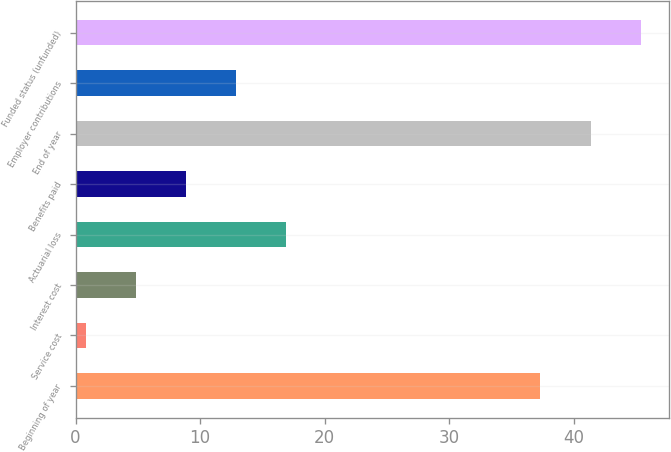<chart> <loc_0><loc_0><loc_500><loc_500><bar_chart><fcel>Beginning of year<fcel>Service cost<fcel>Interest cost<fcel>Actuarial loss<fcel>Benefits paid<fcel>End of year<fcel>Employer contributions<fcel>Funded status (unfunded)<nl><fcel>37.3<fcel>0.8<fcel>4.83<fcel>16.92<fcel>8.86<fcel>41.33<fcel>12.89<fcel>45.36<nl></chart> 